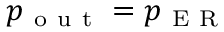<formula> <loc_0><loc_0><loc_500><loc_500>p _ { o u t } = p _ { E R }</formula> 